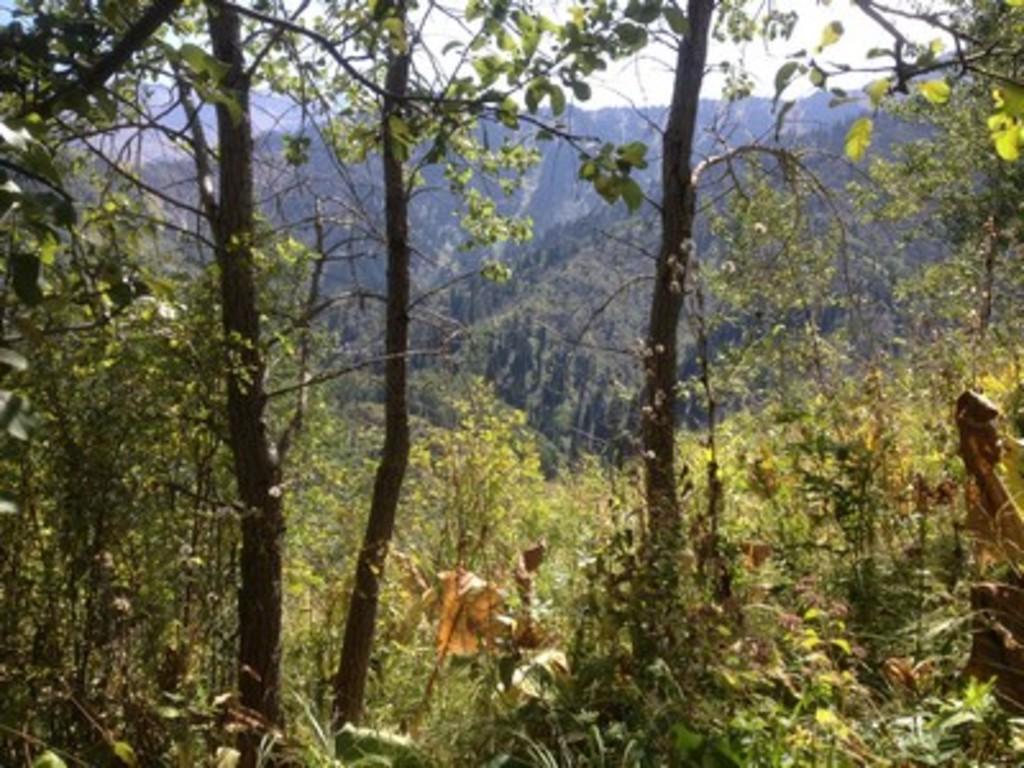Could you give a brief overview of what you see in this image? This picture shows few trees and we see a cloudy sky. 